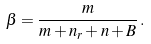<formula> <loc_0><loc_0><loc_500><loc_500>\beta = \frac { m } { m + n _ { r } + n + B } \, .</formula> 